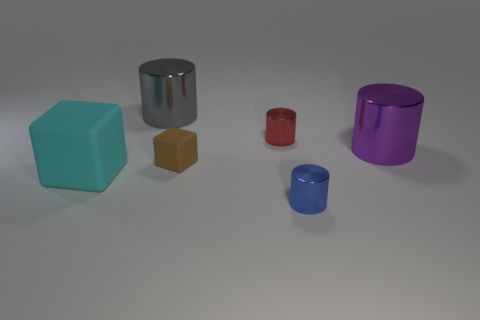Subtract all gray cylinders. How many cylinders are left? 3 Subtract 2 cylinders. How many cylinders are left? 2 Add 3 large gray cylinders. How many objects exist? 9 Subtract all cubes. How many objects are left? 4 Subtract all brown cylinders. Subtract all green balls. How many cylinders are left? 4 Subtract all small blue blocks. Subtract all small blue metallic things. How many objects are left? 5 Add 1 tiny rubber things. How many tiny rubber things are left? 2 Add 2 large yellow blocks. How many large yellow blocks exist? 2 Subtract 0 yellow spheres. How many objects are left? 6 